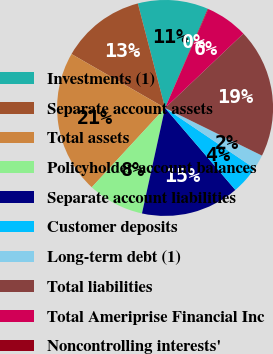Convert chart to OTSL. <chart><loc_0><loc_0><loc_500><loc_500><pie_chart><fcel>Investments (1)<fcel>Separate account assets<fcel>Total assets<fcel>Policyholder account balances<fcel>Separate account liabilities<fcel>Customer deposits<fcel>Long-term debt (1)<fcel>Total liabilities<fcel>Total Ameriprise Financial Inc<fcel>Noncontrolling interests'<nl><fcel>10.53%<fcel>12.62%<fcel>21.45%<fcel>8.44%<fcel>14.71%<fcel>4.27%<fcel>2.18%<fcel>19.36%<fcel>6.35%<fcel>0.09%<nl></chart> 